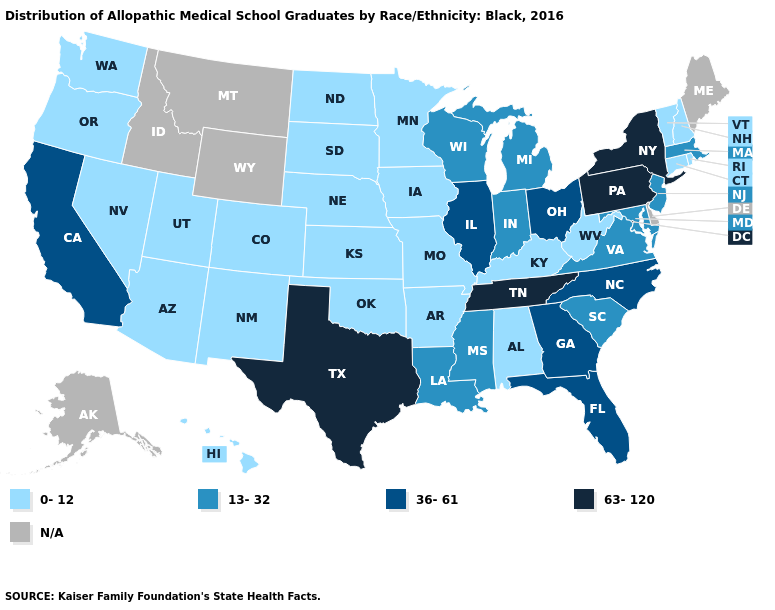What is the lowest value in states that border Missouri?
Short answer required. 0-12. Among the states that border Oklahoma , which have the highest value?
Give a very brief answer. Texas. What is the value of North Dakota?
Give a very brief answer. 0-12. Name the states that have a value in the range 13-32?
Give a very brief answer. Indiana, Louisiana, Maryland, Massachusetts, Michigan, Mississippi, New Jersey, South Carolina, Virginia, Wisconsin. Name the states that have a value in the range 63-120?
Concise answer only. New York, Pennsylvania, Tennessee, Texas. Does Pennsylvania have the highest value in the USA?
Concise answer only. Yes. What is the lowest value in the USA?
Short answer required. 0-12. Does Iowa have the lowest value in the USA?
Write a very short answer. Yes. What is the value of Ohio?
Answer briefly. 36-61. What is the highest value in the West ?
Be succinct. 36-61. Does the map have missing data?
Be succinct. Yes. Does the first symbol in the legend represent the smallest category?
Be succinct. Yes. Name the states that have a value in the range 0-12?
Answer briefly. Alabama, Arizona, Arkansas, Colorado, Connecticut, Hawaii, Iowa, Kansas, Kentucky, Minnesota, Missouri, Nebraska, Nevada, New Hampshire, New Mexico, North Dakota, Oklahoma, Oregon, Rhode Island, South Dakota, Utah, Vermont, Washington, West Virginia. Which states have the highest value in the USA?
Give a very brief answer. New York, Pennsylvania, Tennessee, Texas. 